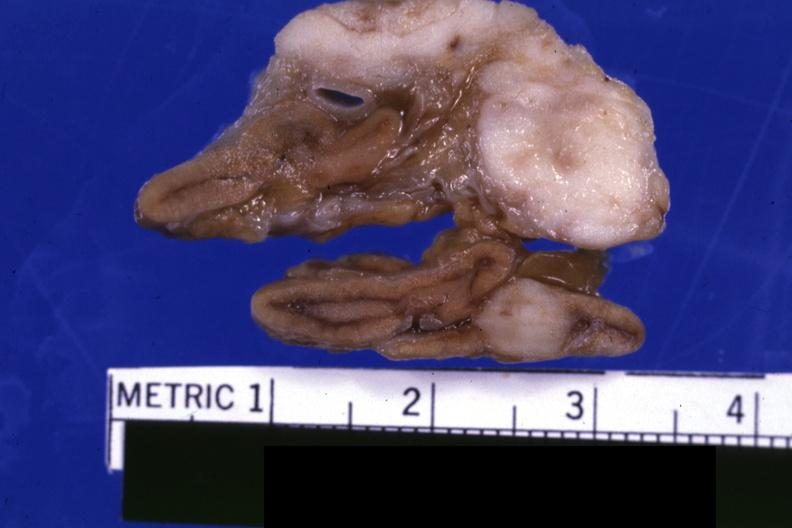where does this belong to?
Answer the question using a single word or phrase. Endocrine system 